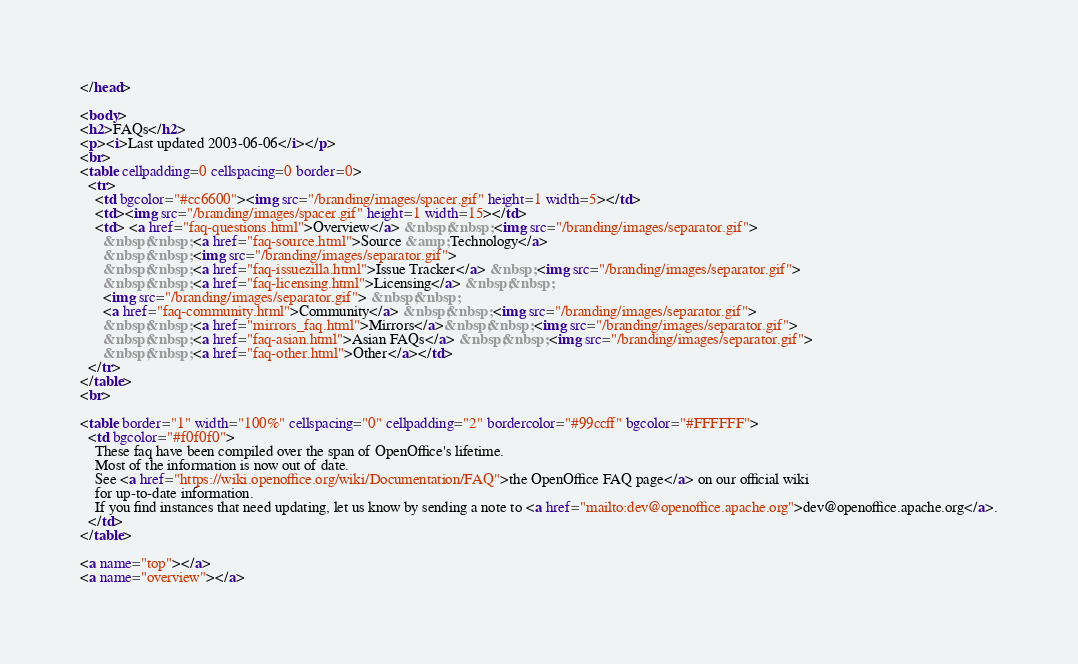Convert code to text. <code><loc_0><loc_0><loc_500><loc_500><_HTML_></head>

<body>
<h2>FAQs</h2>
<p><i>Last updated 2003-06-06</i></p>
<br>
<table cellpadding=0 cellspacing=0 border=0>
  <tr> 
    <td bgcolor="#cc6600"><img src="/branding/images/spacer.gif" height=1 width=5></td>
    <td><img src="/branding/images/spacer.gif" height=1 width=15></td>
    <td> <a href="faq-questions.html">Overview</a> &nbsp;&nbsp; <img src="/branding/images/separator.gif"> 
      &nbsp;&nbsp; <a href="faq-source.html">Source &amp; Technology</a> 
      &nbsp;&nbsp; <img src="/branding/images/separator.gif"> 
      &nbsp;&nbsp; <a href="faq-issuezilla.html">Issue Tracker</a> &nbsp; <img src="/branding/images/separator.gif"> 
      &nbsp;&nbsp; <a href="faq-licensing.html">Licensing</a> &nbsp;&nbsp; 
      <img src="/branding/images/separator.gif"> &nbsp;&nbsp; 
      <a href="faq-community.html">Community</a> &nbsp;&nbsp; <img src="/branding/images/separator.gif"> 
      &nbsp;&nbsp; <a href="mirrors_faq.html">Mirrors</a>&nbsp;&nbsp; <img src="/branding/images/separator.gif"> 
      &nbsp;&nbsp; <a href="faq-asian.html">Asian FAQs</a> &nbsp;&nbsp; <img src="/branding/images/separator.gif"> 
      &nbsp;&nbsp; <a href="faq-other.html">Other</a></td>
  </tr>
</table>
<br>

<table border="1" width="100%" cellspacing="0" cellpadding="2" bordercolor="#99ccff" bgcolor="#FFFFFF">
  <td bgcolor="#f0f0f0">
    These faq have been compiled over the span of OpenOffice's lifetime.
    Most of the information is now out of date.
    See <a href="https://wiki.openoffice.org/wiki/Documentation/FAQ">the OpenOffice FAQ page</a> on our official wiki
    for up-to-date information.
    If you find instances that need updating, let us know by sending a note to <a href="mailto:dev@openoffice.apache.org">dev@openoffice.apache.org</a>.
  </td>
</table>

<a name="top"></a> 
<a name="overview"></a></code> 